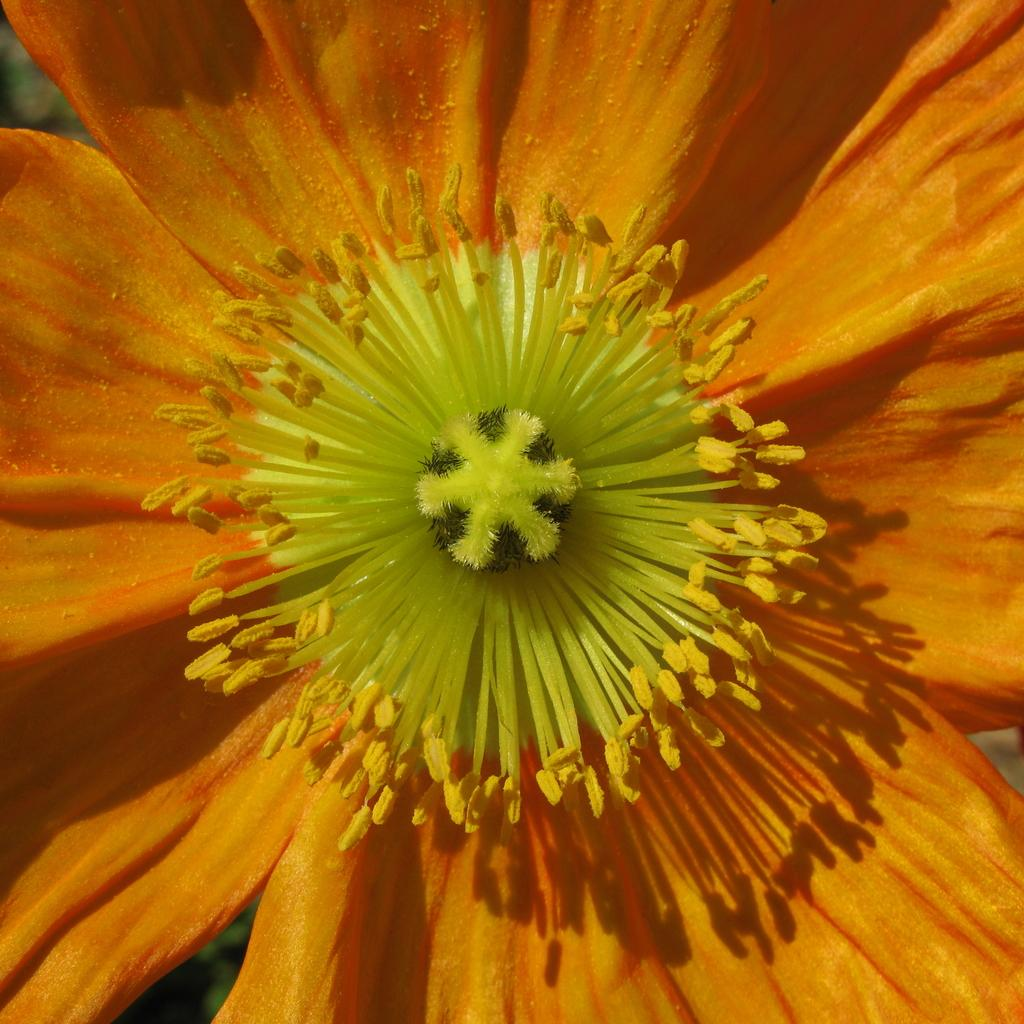What is the main subject of the image? There is a flower in the image. What color is the flower? The flower is orange in color. What type of leather is used to make the bird's nest in the image? There is no bird or nest present in the image, and therefore no leather can be associated with it. 